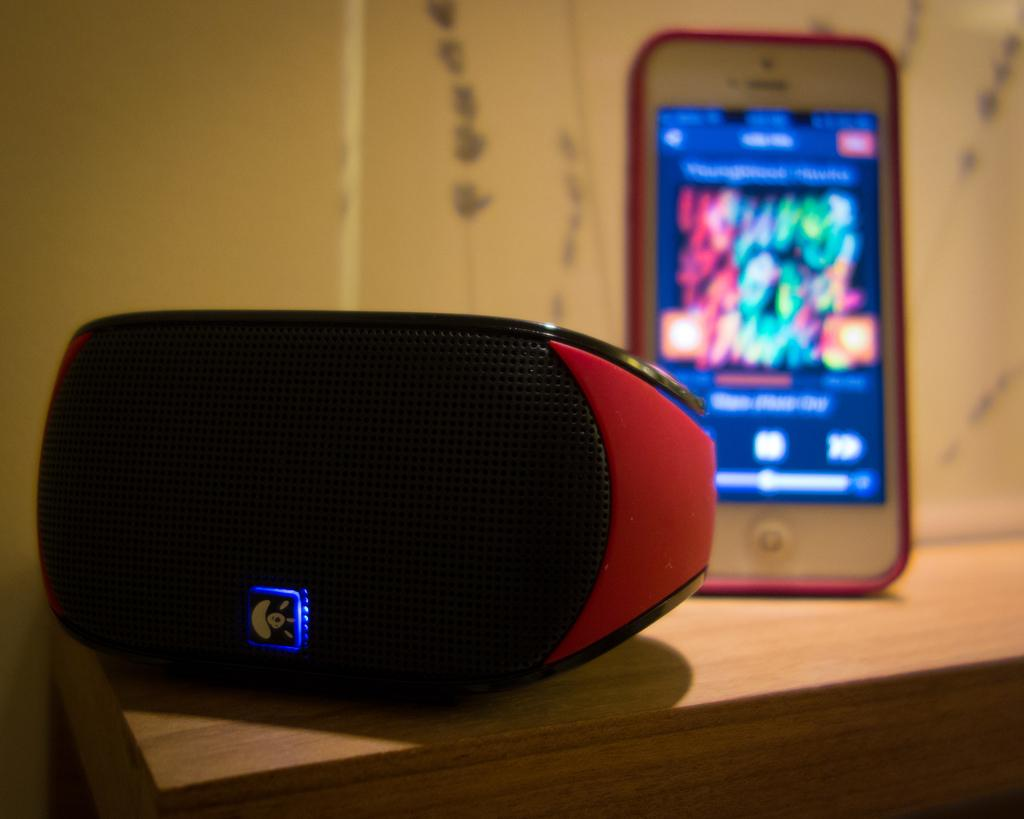What is the main piece of furniture in the image? There is a table in the image. What is placed on the table? A mobile and a speaker are present on the table. Can you describe the design on the wall in the background of the image? There is a design on the wall in the background of the image. How many veins can be seen in the image? There are no veins present in the image. What is the amount of fold in the image? There is no fold present in the image. 